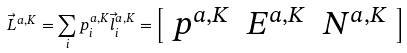<formula> <loc_0><loc_0><loc_500><loc_500>\vec { L } ^ { a , K } = \sum _ { i } p _ { i } ^ { a , K } \vec { l } _ { i } ^ { a , K } = \left [ \begin{array} { c c c } p ^ { a , K } & E ^ { a , K } & N ^ { a , K } \end{array} \right ]</formula> 